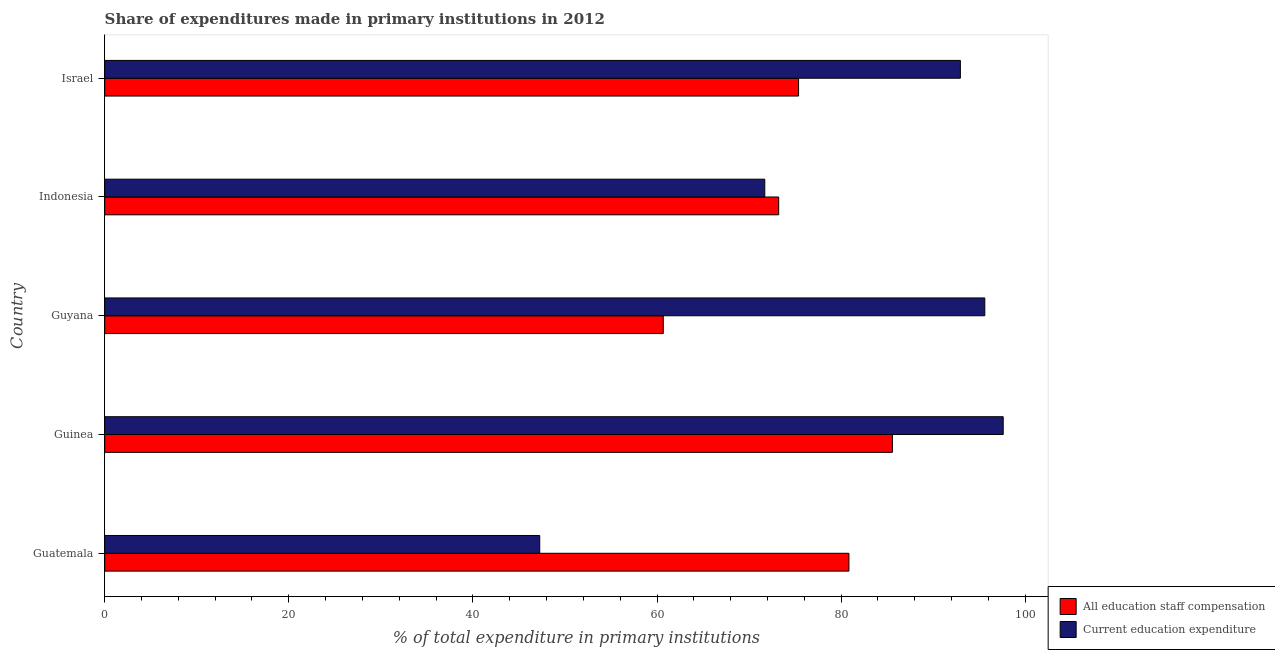How many different coloured bars are there?
Offer a very short reply. 2. Are the number of bars per tick equal to the number of legend labels?
Offer a terse response. Yes. How many bars are there on the 4th tick from the bottom?
Your answer should be compact. 2. What is the label of the 3rd group of bars from the top?
Offer a terse response. Guyana. What is the expenditure in staff compensation in Guatemala?
Make the answer very short. 80.85. Across all countries, what is the maximum expenditure in education?
Your response must be concise. 97.61. Across all countries, what is the minimum expenditure in education?
Keep it short and to the point. 47.26. In which country was the expenditure in education maximum?
Give a very brief answer. Guinea. In which country was the expenditure in education minimum?
Provide a succinct answer. Guatemala. What is the total expenditure in education in the graph?
Make the answer very short. 405.16. What is the difference between the expenditure in education in Guinea and that in Guyana?
Make the answer very short. 2. What is the difference between the expenditure in education in Guyana and the expenditure in staff compensation in Indonesia?
Offer a terse response. 22.39. What is the average expenditure in education per country?
Keep it short and to the point. 81.03. What is the difference between the expenditure in staff compensation and expenditure in education in Guatemala?
Your response must be concise. 33.59. In how many countries, is the expenditure in staff compensation greater than 72 %?
Provide a succinct answer. 4. What is the ratio of the expenditure in staff compensation in Guinea to that in Israel?
Your response must be concise. 1.14. Is the expenditure in education in Guinea less than that in Israel?
Your response must be concise. No. Is the difference between the expenditure in staff compensation in Guatemala and Guyana greater than the difference between the expenditure in education in Guatemala and Guyana?
Your response must be concise. Yes. What is the difference between the highest and the second highest expenditure in staff compensation?
Keep it short and to the point. 4.73. What is the difference between the highest and the lowest expenditure in education?
Give a very brief answer. 50.35. What does the 1st bar from the top in Guyana represents?
Provide a short and direct response. Current education expenditure. What does the 2nd bar from the bottom in Indonesia represents?
Provide a short and direct response. Current education expenditure. Are all the bars in the graph horizontal?
Provide a succinct answer. Yes. How many countries are there in the graph?
Ensure brevity in your answer.  5. What is the difference between two consecutive major ticks on the X-axis?
Provide a succinct answer. 20. Are the values on the major ticks of X-axis written in scientific E-notation?
Keep it short and to the point. No. How many legend labels are there?
Your response must be concise. 2. What is the title of the graph?
Your answer should be very brief. Share of expenditures made in primary institutions in 2012. Does "Electricity and heat production" appear as one of the legend labels in the graph?
Your answer should be very brief. No. What is the label or title of the X-axis?
Offer a terse response. % of total expenditure in primary institutions. What is the label or title of the Y-axis?
Your answer should be compact. Country. What is the % of total expenditure in primary institutions in All education staff compensation in Guatemala?
Provide a succinct answer. 80.85. What is the % of total expenditure in primary institutions in Current education expenditure in Guatemala?
Offer a terse response. 47.26. What is the % of total expenditure in primary institutions in All education staff compensation in Guinea?
Ensure brevity in your answer.  85.58. What is the % of total expenditure in primary institutions of Current education expenditure in Guinea?
Provide a succinct answer. 97.61. What is the % of total expenditure in primary institutions of All education staff compensation in Guyana?
Ensure brevity in your answer.  60.68. What is the % of total expenditure in primary institutions of Current education expenditure in Guyana?
Give a very brief answer. 95.61. What is the % of total expenditure in primary institutions in All education staff compensation in Indonesia?
Your response must be concise. 73.22. What is the % of total expenditure in primary institutions of Current education expenditure in Indonesia?
Provide a succinct answer. 71.71. What is the % of total expenditure in primary institutions in All education staff compensation in Israel?
Keep it short and to the point. 75.38. What is the % of total expenditure in primary institutions in Current education expenditure in Israel?
Offer a terse response. 92.96. Across all countries, what is the maximum % of total expenditure in primary institutions of All education staff compensation?
Give a very brief answer. 85.58. Across all countries, what is the maximum % of total expenditure in primary institutions of Current education expenditure?
Make the answer very short. 97.61. Across all countries, what is the minimum % of total expenditure in primary institutions of All education staff compensation?
Ensure brevity in your answer.  60.68. Across all countries, what is the minimum % of total expenditure in primary institutions in Current education expenditure?
Ensure brevity in your answer.  47.26. What is the total % of total expenditure in primary institutions in All education staff compensation in the graph?
Keep it short and to the point. 375.71. What is the total % of total expenditure in primary institutions in Current education expenditure in the graph?
Make the answer very short. 405.16. What is the difference between the % of total expenditure in primary institutions of All education staff compensation in Guatemala and that in Guinea?
Your answer should be very brief. -4.73. What is the difference between the % of total expenditure in primary institutions in Current education expenditure in Guatemala and that in Guinea?
Give a very brief answer. -50.35. What is the difference between the % of total expenditure in primary institutions of All education staff compensation in Guatemala and that in Guyana?
Provide a succinct answer. 20.17. What is the difference between the % of total expenditure in primary institutions in Current education expenditure in Guatemala and that in Guyana?
Your response must be concise. -48.35. What is the difference between the % of total expenditure in primary institutions of All education staff compensation in Guatemala and that in Indonesia?
Your response must be concise. 7.63. What is the difference between the % of total expenditure in primary institutions in Current education expenditure in Guatemala and that in Indonesia?
Your answer should be compact. -24.45. What is the difference between the % of total expenditure in primary institutions of All education staff compensation in Guatemala and that in Israel?
Provide a short and direct response. 5.47. What is the difference between the % of total expenditure in primary institutions of Current education expenditure in Guatemala and that in Israel?
Make the answer very short. -45.7. What is the difference between the % of total expenditure in primary institutions in All education staff compensation in Guinea and that in Guyana?
Your answer should be compact. 24.9. What is the difference between the % of total expenditure in primary institutions of Current education expenditure in Guinea and that in Guyana?
Ensure brevity in your answer.  2. What is the difference between the % of total expenditure in primary institutions in All education staff compensation in Guinea and that in Indonesia?
Offer a terse response. 12.36. What is the difference between the % of total expenditure in primary institutions in Current education expenditure in Guinea and that in Indonesia?
Provide a short and direct response. 25.9. What is the difference between the % of total expenditure in primary institutions of All education staff compensation in Guinea and that in Israel?
Make the answer very short. 10.2. What is the difference between the % of total expenditure in primary institutions in Current education expenditure in Guinea and that in Israel?
Your answer should be compact. 4.66. What is the difference between the % of total expenditure in primary institutions in All education staff compensation in Guyana and that in Indonesia?
Keep it short and to the point. -12.54. What is the difference between the % of total expenditure in primary institutions in Current education expenditure in Guyana and that in Indonesia?
Make the answer very short. 23.9. What is the difference between the % of total expenditure in primary institutions in All education staff compensation in Guyana and that in Israel?
Your answer should be compact. -14.7. What is the difference between the % of total expenditure in primary institutions of Current education expenditure in Guyana and that in Israel?
Keep it short and to the point. 2.65. What is the difference between the % of total expenditure in primary institutions of All education staff compensation in Indonesia and that in Israel?
Provide a short and direct response. -2.16. What is the difference between the % of total expenditure in primary institutions in Current education expenditure in Indonesia and that in Israel?
Provide a succinct answer. -21.25. What is the difference between the % of total expenditure in primary institutions in All education staff compensation in Guatemala and the % of total expenditure in primary institutions in Current education expenditure in Guinea?
Your answer should be compact. -16.76. What is the difference between the % of total expenditure in primary institutions of All education staff compensation in Guatemala and the % of total expenditure in primary institutions of Current education expenditure in Guyana?
Your answer should be compact. -14.76. What is the difference between the % of total expenditure in primary institutions in All education staff compensation in Guatemala and the % of total expenditure in primary institutions in Current education expenditure in Indonesia?
Your response must be concise. 9.14. What is the difference between the % of total expenditure in primary institutions of All education staff compensation in Guatemala and the % of total expenditure in primary institutions of Current education expenditure in Israel?
Your answer should be compact. -12.11. What is the difference between the % of total expenditure in primary institutions of All education staff compensation in Guinea and the % of total expenditure in primary institutions of Current education expenditure in Guyana?
Ensure brevity in your answer.  -10.04. What is the difference between the % of total expenditure in primary institutions in All education staff compensation in Guinea and the % of total expenditure in primary institutions in Current education expenditure in Indonesia?
Make the answer very short. 13.87. What is the difference between the % of total expenditure in primary institutions in All education staff compensation in Guinea and the % of total expenditure in primary institutions in Current education expenditure in Israel?
Provide a short and direct response. -7.38. What is the difference between the % of total expenditure in primary institutions of All education staff compensation in Guyana and the % of total expenditure in primary institutions of Current education expenditure in Indonesia?
Your response must be concise. -11.03. What is the difference between the % of total expenditure in primary institutions in All education staff compensation in Guyana and the % of total expenditure in primary institutions in Current education expenditure in Israel?
Make the answer very short. -32.28. What is the difference between the % of total expenditure in primary institutions of All education staff compensation in Indonesia and the % of total expenditure in primary institutions of Current education expenditure in Israel?
Your answer should be compact. -19.74. What is the average % of total expenditure in primary institutions of All education staff compensation per country?
Provide a short and direct response. 75.14. What is the average % of total expenditure in primary institutions in Current education expenditure per country?
Your answer should be very brief. 81.03. What is the difference between the % of total expenditure in primary institutions of All education staff compensation and % of total expenditure in primary institutions of Current education expenditure in Guatemala?
Ensure brevity in your answer.  33.59. What is the difference between the % of total expenditure in primary institutions of All education staff compensation and % of total expenditure in primary institutions of Current education expenditure in Guinea?
Provide a succinct answer. -12.04. What is the difference between the % of total expenditure in primary institutions in All education staff compensation and % of total expenditure in primary institutions in Current education expenditure in Guyana?
Your answer should be very brief. -34.93. What is the difference between the % of total expenditure in primary institutions in All education staff compensation and % of total expenditure in primary institutions in Current education expenditure in Indonesia?
Offer a terse response. 1.51. What is the difference between the % of total expenditure in primary institutions of All education staff compensation and % of total expenditure in primary institutions of Current education expenditure in Israel?
Ensure brevity in your answer.  -17.58. What is the ratio of the % of total expenditure in primary institutions in All education staff compensation in Guatemala to that in Guinea?
Provide a short and direct response. 0.94. What is the ratio of the % of total expenditure in primary institutions in Current education expenditure in Guatemala to that in Guinea?
Make the answer very short. 0.48. What is the ratio of the % of total expenditure in primary institutions in All education staff compensation in Guatemala to that in Guyana?
Keep it short and to the point. 1.33. What is the ratio of the % of total expenditure in primary institutions of Current education expenditure in Guatemala to that in Guyana?
Offer a terse response. 0.49. What is the ratio of the % of total expenditure in primary institutions in All education staff compensation in Guatemala to that in Indonesia?
Your response must be concise. 1.1. What is the ratio of the % of total expenditure in primary institutions of Current education expenditure in Guatemala to that in Indonesia?
Make the answer very short. 0.66. What is the ratio of the % of total expenditure in primary institutions in All education staff compensation in Guatemala to that in Israel?
Offer a terse response. 1.07. What is the ratio of the % of total expenditure in primary institutions of Current education expenditure in Guatemala to that in Israel?
Offer a very short reply. 0.51. What is the ratio of the % of total expenditure in primary institutions in All education staff compensation in Guinea to that in Guyana?
Your answer should be very brief. 1.41. What is the ratio of the % of total expenditure in primary institutions of Current education expenditure in Guinea to that in Guyana?
Your answer should be compact. 1.02. What is the ratio of the % of total expenditure in primary institutions of All education staff compensation in Guinea to that in Indonesia?
Your response must be concise. 1.17. What is the ratio of the % of total expenditure in primary institutions of Current education expenditure in Guinea to that in Indonesia?
Offer a very short reply. 1.36. What is the ratio of the % of total expenditure in primary institutions of All education staff compensation in Guinea to that in Israel?
Provide a short and direct response. 1.14. What is the ratio of the % of total expenditure in primary institutions in Current education expenditure in Guinea to that in Israel?
Make the answer very short. 1.05. What is the ratio of the % of total expenditure in primary institutions of All education staff compensation in Guyana to that in Indonesia?
Provide a short and direct response. 0.83. What is the ratio of the % of total expenditure in primary institutions of Current education expenditure in Guyana to that in Indonesia?
Ensure brevity in your answer.  1.33. What is the ratio of the % of total expenditure in primary institutions in All education staff compensation in Guyana to that in Israel?
Your answer should be compact. 0.81. What is the ratio of the % of total expenditure in primary institutions of Current education expenditure in Guyana to that in Israel?
Make the answer very short. 1.03. What is the ratio of the % of total expenditure in primary institutions of All education staff compensation in Indonesia to that in Israel?
Your answer should be compact. 0.97. What is the ratio of the % of total expenditure in primary institutions of Current education expenditure in Indonesia to that in Israel?
Offer a very short reply. 0.77. What is the difference between the highest and the second highest % of total expenditure in primary institutions of All education staff compensation?
Make the answer very short. 4.73. What is the difference between the highest and the second highest % of total expenditure in primary institutions of Current education expenditure?
Provide a succinct answer. 2. What is the difference between the highest and the lowest % of total expenditure in primary institutions of All education staff compensation?
Keep it short and to the point. 24.9. What is the difference between the highest and the lowest % of total expenditure in primary institutions in Current education expenditure?
Provide a short and direct response. 50.35. 